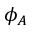Convert formula to latex. <formula><loc_0><loc_0><loc_500><loc_500>\phi _ { A }</formula> 